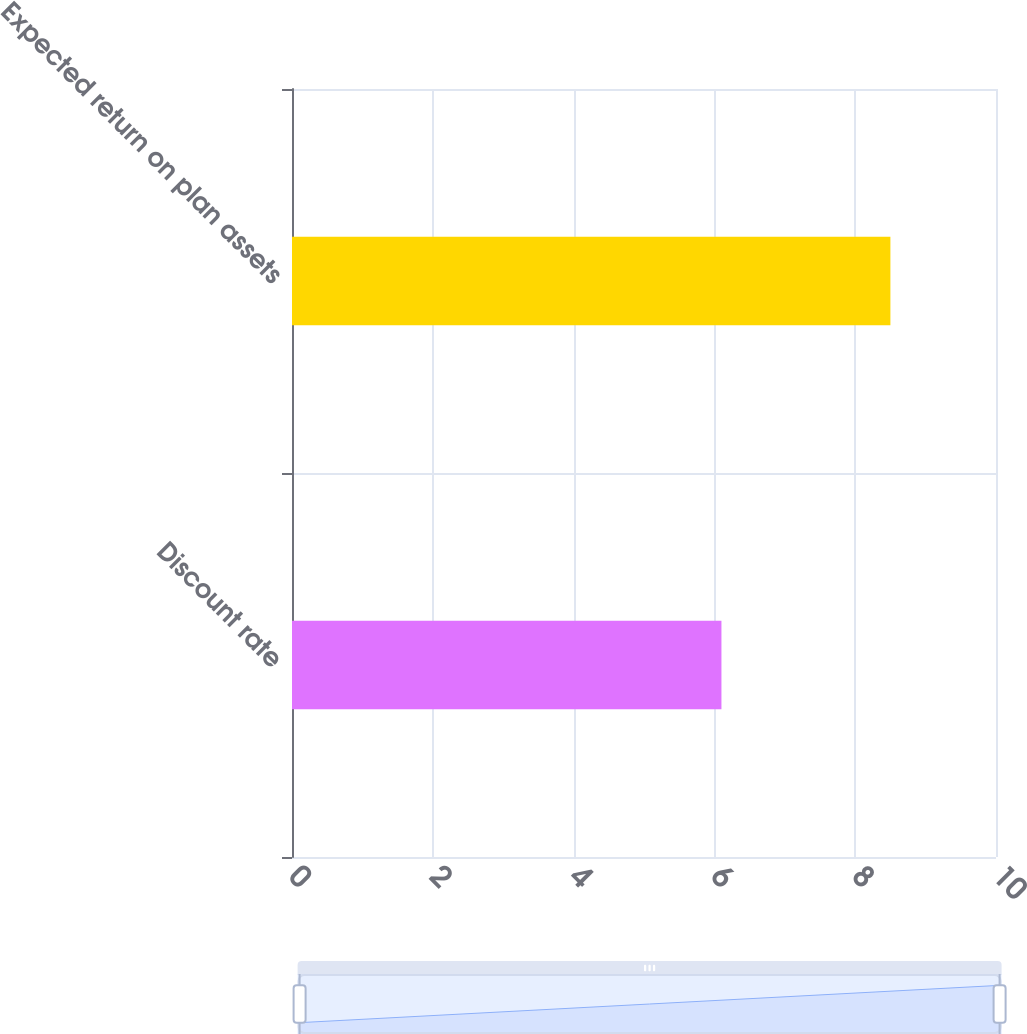<chart> <loc_0><loc_0><loc_500><loc_500><bar_chart><fcel>Discount rate<fcel>Expected return on plan assets<nl><fcel>6.1<fcel>8.5<nl></chart> 